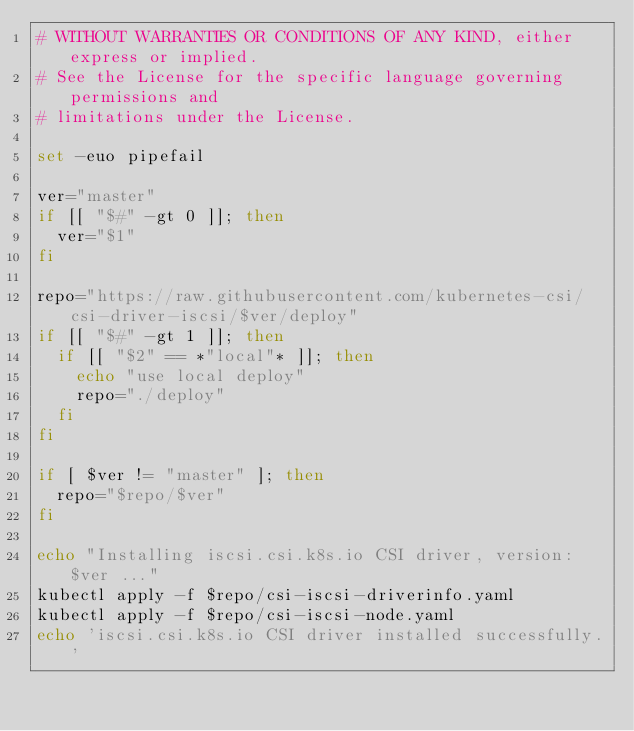Convert code to text. <code><loc_0><loc_0><loc_500><loc_500><_Bash_># WITHOUT WARRANTIES OR CONDITIONS OF ANY KIND, either express or implied.
# See the License for the specific language governing permissions and
# limitations under the License.

set -euo pipefail

ver="master"
if [[ "$#" -gt 0 ]]; then
  ver="$1"
fi

repo="https://raw.githubusercontent.com/kubernetes-csi/csi-driver-iscsi/$ver/deploy"
if [[ "$#" -gt 1 ]]; then
  if [[ "$2" == *"local"* ]]; then
    echo "use local deploy"
    repo="./deploy"
  fi
fi

if [ $ver != "master" ]; then
  repo="$repo/$ver"
fi

echo "Installing iscsi.csi.k8s.io CSI driver, version: $ver ..."
kubectl apply -f $repo/csi-iscsi-driverinfo.yaml
kubectl apply -f $repo/csi-iscsi-node.yaml
echo 'iscsi.csi.k8s.io CSI driver installed successfully.'
</code> 